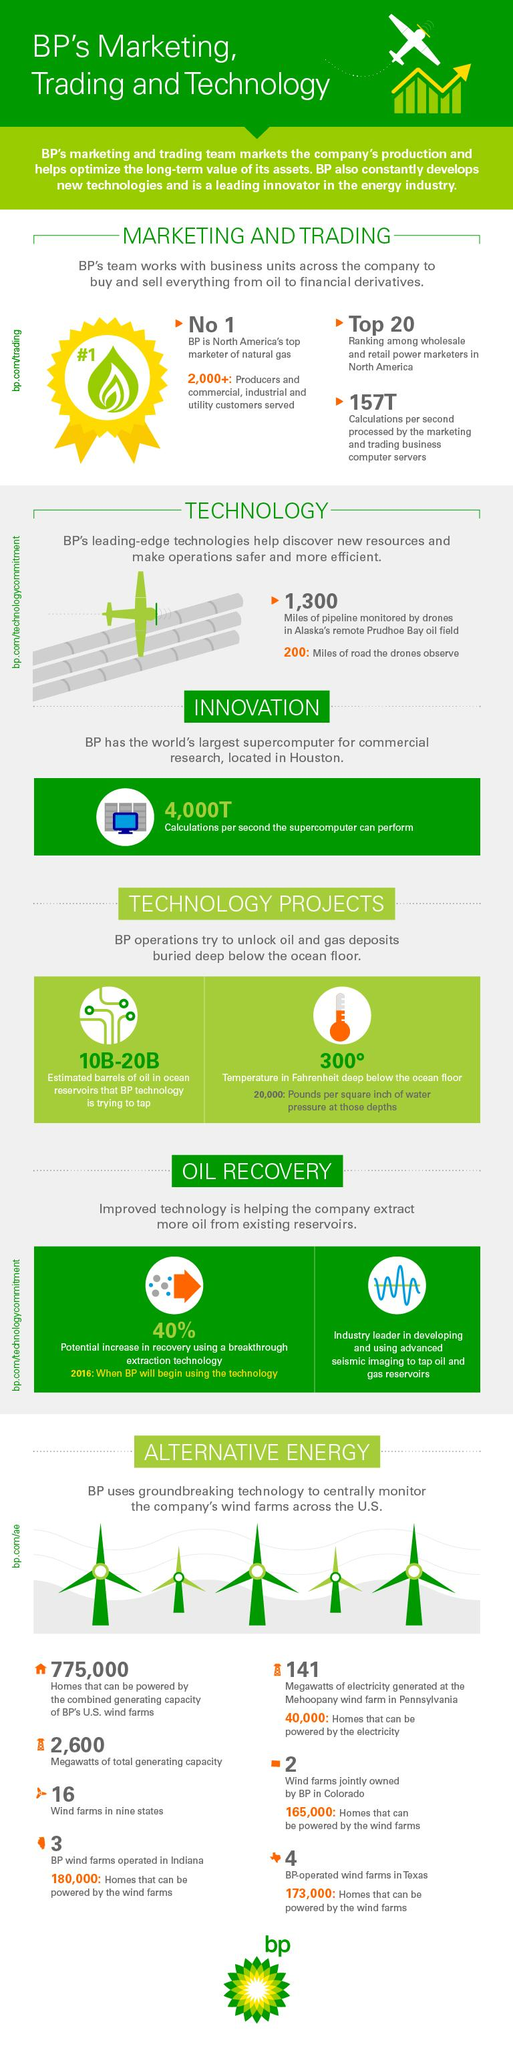Mention a couple of crucial points in this snapshot. BP's U.S. wind farms have a combined generating capacity of 775,000 homes, which is sufficient to power 775,000 homes in the United States. The Mehoopany wind farm in Pennsylvania generates 141 megawatts of electricity. The temperature in Fahrenheit deep below the ocean floor is 300° Fahrenheit. The estimated amount of oil reserves in ocean reservoirs that BP technology is attempting to tap ranges from 10 billion to 20 billion barrels. There are currently four BP-operated wind farms in Texas. 